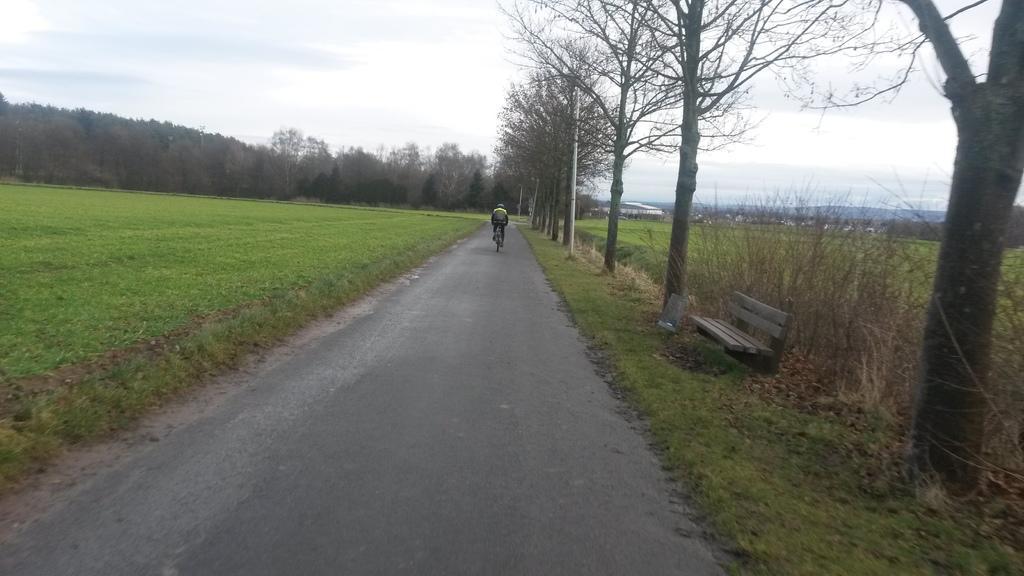How would you summarize this image in a sentence or two? In this picture we can see a person riding a bicycle and in the background we can see trees,sky. 